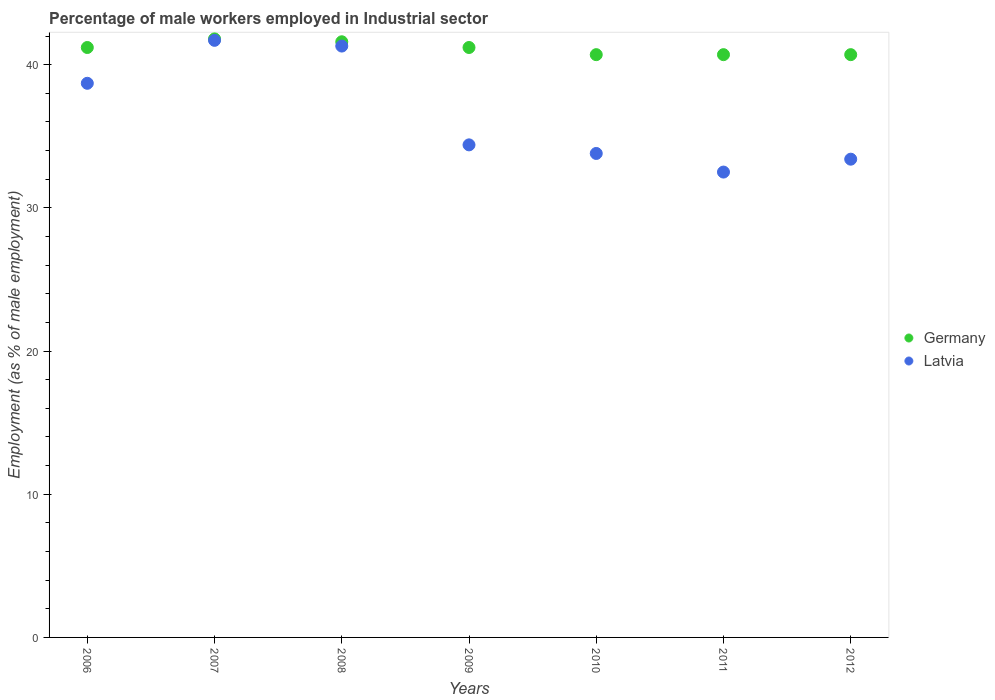What is the percentage of male workers employed in Industrial sector in Germany in 2006?
Your answer should be very brief. 41.2. Across all years, what is the maximum percentage of male workers employed in Industrial sector in Germany?
Provide a succinct answer. 41.8. Across all years, what is the minimum percentage of male workers employed in Industrial sector in Germany?
Your answer should be compact. 40.7. What is the total percentage of male workers employed in Industrial sector in Latvia in the graph?
Give a very brief answer. 255.8. What is the difference between the percentage of male workers employed in Industrial sector in Latvia in 2006 and the percentage of male workers employed in Industrial sector in Germany in 2008?
Your answer should be compact. -2.9. What is the average percentage of male workers employed in Industrial sector in Germany per year?
Your response must be concise. 41.13. In the year 2009, what is the difference between the percentage of male workers employed in Industrial sector in Germany and percentage of male workers employed in Industrial sector in Latvia?
Provide a succinct answer. 6.8. What is the ratio of the percentage of male workers employed in Industrial sector in Germany in 2008 to that in 2012?
Make the answer very short. 1.02. Is the percentage of male workers employed in Industrial sector in Latvia in 2009 less than that in 2010?
Offer a very short reply. No. What is the difference between the highest and the second highest percentage of male workers employed in Industrial sector in Latvia?
Keep it short and to the point. 0.4. What is the difference between the highest and the lowest percentage of male workers employed in Industrial sector in Germany?
Provide a succinct answer. 1.1. In how many years, is the percentage of male workers employed in Industrial sector in Latvia greater than the average percentage of male workers employed in Industrial sector in Latvia taken over all years?
Make the answer very short. 3. Does the percentage of male workers employed in Industrial sector in Germany monotonically increase over the years?
Provide a short and direct response. No. How many dotlines are there?
Offer a very short reply. 2. How many years are there in the graph?
Make the answer very short. 7. What is the difference between two consecutive major ticks on the Y-axis?
Offer a terse response. 10. Are the values on the major ticks of Y-axis written in scientific E-notation?
Your answer should be compact. No. Does the graph contain any zero values?
Make the answer very short. No. How many legend labels are there?
Keep it short and to the point. 2. What is the title of the graph?
Your answer should be compact. Percentage of male workers employed in Industrial sector. Does "Guam" appear as one of the legend labels in the graph?
Ensure brevity in your answer.  No. What is the label or title of the X-axis?
Keep it short and to the point. Years. What is the label or title of the Y-axis?
Your response must be concise. Employment (as % of male employment). What is the Employment (as % of male employment) in Germany in 2006?
Give a very brief answer. 41.2. What is the Employment (as % of male employment) in Latvia in 2006?
Ensure brevity in your answer.  38.7. What is the Employment (as % of male employment) in Germany in 2007?
Offer a terse response. 41.8. What is the Employment (as % of male employment) in Latvia in 2007?
Your response must be concise. 41.7. What is the Employment (as % of male employment) of Germany in 2008?
Keep it short and to the point. 41.6. What is the Employment (as % of male employment) in Latvia in 2008?
Offer a terse response. 41.3. What is the Employment (as % of male employment) in Germany in 2009?
Provide a short and direct response. 41.2. What is the Employment (as % of male employment) of Latvia in 2009?
Keep it short and to the point. 34.4. What is the Employment (as % of male employment) of Germany in 2010?
Provide a succinct answer. 40.7. What is the Employment (as % of male employment) of Latvia in 2010?
Your answer should be compact. 33.8. What is the Employment (as % of male employment) of Germany in 2011?
Offer a terse response. 40.7. What is the Employment (as % of male employment) of Latvia in 2011?
Your answer should be compact. 32.5. What is the Employment (as % of male employment) in Germany in 2012?
Your answer should be compact. 40.7. What is the Employment (as % of male employment) in Latvia in 2012?
Provide a succinct answer. 33.4. Across all years, what is the maximum Employment (as % of male employment) of Germany?
Offer a terse response. 41.8. Across all years, what is the maximum Employment (as % of male employment) in Latvia?
Give a very brief answer. 41.7. Across all years, what is the minimum Employment (as % of male employment) of Germany?
Offer a very short reply. 40.7. Across all years, what is the minimum Employment (as % of male employment) of Latvia?
Provide a succinct answer. 32.5. What is the total Employment (as % of male employment) of Germany in the graph?
Offer a terse response. 287.9. What is the total Employment (as % of male employment) of Latvia in the graph?
Offer a terse response. 255.8. What is the difference between the Employment (as % of male employment) in Germany in 2006 and that in 2007?
Offer a terse response. -0.6. What is the difference between the Employment (as % of male employment) in Germany in 2006 and that in 2008?
Offer a terse response. -0.4. What is the difference between the Employment (as % of male employment) in Latvia in 2006 and that in 2008?
Offer a terse response. -2.6. What is the difference between the Employment (as % of male employment) in Latvia in 2006 and that in 2010?
Give a very brief answer. 4.9. What is the difference between the Employment (as % of male employment) in Latvia in 2006 and that in 2011?
Your response must be concise. 6.2. What is the difference between the Employment (as % of male employment) of Germany in 2006 and that in 2012?
Your answer should be very brief. 0.5. What is the difference between the Employment (as % of male employment) in Germany in 2007 and that in 2008?
Provide a succinct answer. 0.2. What is the difference between the Employment (as % of male employment) in Latvia in 2007 and that in 2008?
Your answer should be compact. 0.4. What is the difference between the Employment (as % of male employment) in Latvia in 2007 and that in 2009?
Provide a succinct answer. 7.3. What is the difference between the Employment (as % of male employment) of Germany in 2007 and that in 2010?
Your response must be concise. 1.1. What is the difference between the Employment (as % of male employment) of Latvia in 2007 and that in 2010?
Give a very brief answer. 7.9. What is the difference between the Employment (as % of male employment) in Germany in 2007 and that in 2011?
Your response must be concise. 1.1. What is the difference between the Employment (as % of male employment) in Latvia in 2007 and that in 2011?
Keep it short and to the point. 9.2. What is the difference between the Employment (as % of male employment) in Germany in 2007 and that in 2012?
Your answer should be very brief. 1.1. What is the difference between the Employment (as % of male employment) of Latvia in 2007 and that in 2012?
Your answer should be very brief. 8.3. What is the difference between the Employment (as % of male employment) of Latvia in 2008 and that in 2011?
Ensure brevity in your answer.  8.8. What is the difference between the Employment (as % of male employment) in Germany in 2009 and that in 2012?
Provide a succinct answer. 0.5. What is the difference between the Employment (as % of male employment) of Germany in 2010 and that in 2012?
Ensure brevity in your answer.  0. What is the difference between the Employment (as % of male employment) of Germany in 2006 and the Employment (as % of male employment) of Latvia in 2007?
Offer a very short reply. -0.5. What is the difference between the Employment (as % of male employment) of Germany in 2006 and the Employment (as % of male employment) of Latvia in 2008?
Your response must be concise. -0.1. What is the difference between the Employment (as % of male employment) of Germany in 2007 and the Employment (as % of male employment) of Latvia in 2010?
Provide a succinct answer. 8. What is the difference between the Employment (as % of male employment) of Germany in 2007 and the Employment (as % of male employment) of Latvia in 2011?
Ensure brevity in your answer.  9.3. What is the difference between the Employment (as % of male employment) in Germany in 2007 and the Employment (as % of male employment) in Latvia in 2012?
Your answer should be compact. 8.4. What is the difference between the Employment (as % of male employment) of Germany in 2008 and the Employment (as % of male employment) of Latvia in 2009?
Make the answer very short. 7.2. What is the difference between the Employment (as % of male employment) in Germany in 2008 and the Employment (as % of male employment) in Latvia in 2010?
Your answer should be compact. 7.8. What is the difference between the Employment (as % of male employment) of Germany in 2008 and the Employment (as % of male employment) of Latvia in 2012?
Make the answer very short. 8.2. What is the difference between the Employment (as % of male employment) in Germany in 2009 and the Employment (as % of male employment) in Latvia in 2011?
Provide a succinct answer. 8.7. What is the average Employment (as % of male employment) in Germany per year?
Make the answer very short. 41.13. What is the average Employment (as % of male employment) of Latvia per year?
Provide a short and direct response. 36.54. In the year 2007, what is the difference between the Employment (as % of male employment) of Germany and Employment (as % of male employment) of Latvia?
Offer a very short reply. 0.1. In the year 2008, what is the difference between the Employment (as % of male employment) in Germany and Employment (as % of male employment) in Latvia?
Make the answer very short. 0.3. In the year 2012, what is the difference between the Employment (as % of male employment) in Germany and Employment (as % of male employment) in Latvia?
Offer a terse response. 7.3. What is the ratio of the Employment (as % of male employment) of Germany in 2006 to that in 2007?
Provide a succinct answer. 0.99. What is the ratio of the Employment (as % of male employment) of Latvia in 2006 to that in 2007?
Your answer should be very brief. 0.93. What is the ratio of the Employment (as % of male employment) in Germany in 2006 to that in 2008?
Ensure brevity in your answer.  0.99. What is the ratio of the Employment (as % of male employment) in Latvia in 2006 to that in 2008?
Offer a terse response. 0.94. What is the ratio of the Employment (as % of male employment) in Germany in 2006 to that in 2009?
Make the answer very short. 1. What is the ratio of the Employment (as % of male employment) of Germany in 2006 to that in 2010?
Your response must be concise. 1.01. What is the ratio of the Employment (as % of male employment) of Latvia in 2006 to that in 2010?
Offer a terse response. 1.15. What is the ratio of the Employment (as % of male employment) in Germany in 2006 to that in 2011?
Offer a very short reply. 1.01. What is the ratio of the Employment (as % of male employment) of Latvia in 2006 to that in 2011?
Provide a succinct answer. 1.19. What is the ratio of the Employment (as % of male employment) of Germany in 2006 to that in 2012?
Ensure brevity in your answer.  1.01. What is the ratio of the Employment (as % of male employment) of Latvia in 2006 to that in 2012?
Offer a very short reply. 1.16. What is the ratio of the Employment (as % of male employment) of Germany in 2007 to that in 2008?
Provide a short and direct response. 1. What is the ratio of the Employment (as % of male employment) in Latvia in 2007 to that in 2008?
Your answer should be compact. 1.01. What is the ratio of the Employment (as % of male employment) in Germany in 2007 to that in 2009?
Your answer should be very brief. 1.01. What is the ratio of the Employment (as % of male employment) of Latvia in 2007 to that in 2009?
Your answer should be very brief. 1.21. What is the ratio of the Employment (as % of male employment) in Germany in 2007 to that in 2010?
Ensure brevity in your answer.  1.03. What is the ratio of the Employment (as % of male employment) of Latvia in 2007 to that in 2010?
Offer a very short reply. 1.23. What is the ratio of the Employment (as % of male employment) in Latvia in 2007 to that in 2011?
Ensure brevity in your answer.  1.28. What is the ratio of the Employment (as % of male employment) in Germany in 2007 to that in 2012?
Your answer should be compact. 1.03. What is the ratio of the Employment (as % of male employment) in Latvia in 2007 to that in 2012?
Your answer should be very brief. 1.25. What is the ratio of the Employment (as % of male employment) of Germany in 2008 to that in 2009?
Your answer should be compact. 1.01. What is the ratio of the Employment (as % of male employment) in Latvia in 2008 to that in 2009?
Give a very brief answer. 1.2. What is the ratio of the Employment (as % of male employment) in Germany in 2008 to that in 2010?
Offer a very short reply. 1.02. What is the ratio of the Employment (as % of male employment) of Latvia in 2008 to that in 2010?
Provide a short and direct response. 1.22. What is the ratio of the Employment (as % of male employment) of Germany in 2008 to that in 2011?
Provide a succinct answer. 1.02. What is the ratio of the Employment (as % of male employment) in Latvia in 2008 to that in 2011?
Your answer should be very brief. 1.27. What is the ratio of the Employment (as % of male employment) of Germany in 2008 to that in 2012?
Your response must be concise. 1.02. What is the ratio of the Employment (as % of male employment) of Latvia in 2008 to that in 2012?
Give a very brief answer. 1.24. What is the ratio of the Employment (as % of male employment) of Germany in 2009 to that in 2010?
Your answer should be very brief. 1.01. What is the ratio of the Employment (as % of male employment) of Latvia in 2009 to that in 2010?
Give a very brief answer. 1.02. What is the ratio of the Employment (as % of male employment) of Germany in 2009 to that in 2011?
Offer a terse response. 1.01. What is the ratio of the Employment (as % of male employment) in Latvia in 2009 to that in 2011?
Offer a very short reply. 1.06. What is the ratio of the Employment (as % of male employment) of Germany in 2009 to that in 2012?
Ensure brevity in your answer.  1.01. What is the ratio of the Employment (as % of male employment) of Latvia in 2009 to that in 2012?
Give a very brief answer. 1.03. What is the ratio of the Employment (as % of male employment) in Germany in 2010 to that in 2011?
Your answer should be compact. 1. What is the ratio of the Employment (as % of male employment) of Latvia in 2010 to that in 2012?
Your answer should be compact. 1.01. What is the ratio of the Employment (as % of male employment) of Latvia in 2011 to that in 2012?
Your response must be concise. 0.97. What is the difference between the highest and the second highest Employment (as % of male employment) in Germany?
Your response must be concise. 0.2. What is the difference between the highest and the lowest Employment (as % of male employment) of Latvia?
Make the answer very short. 9.2. 